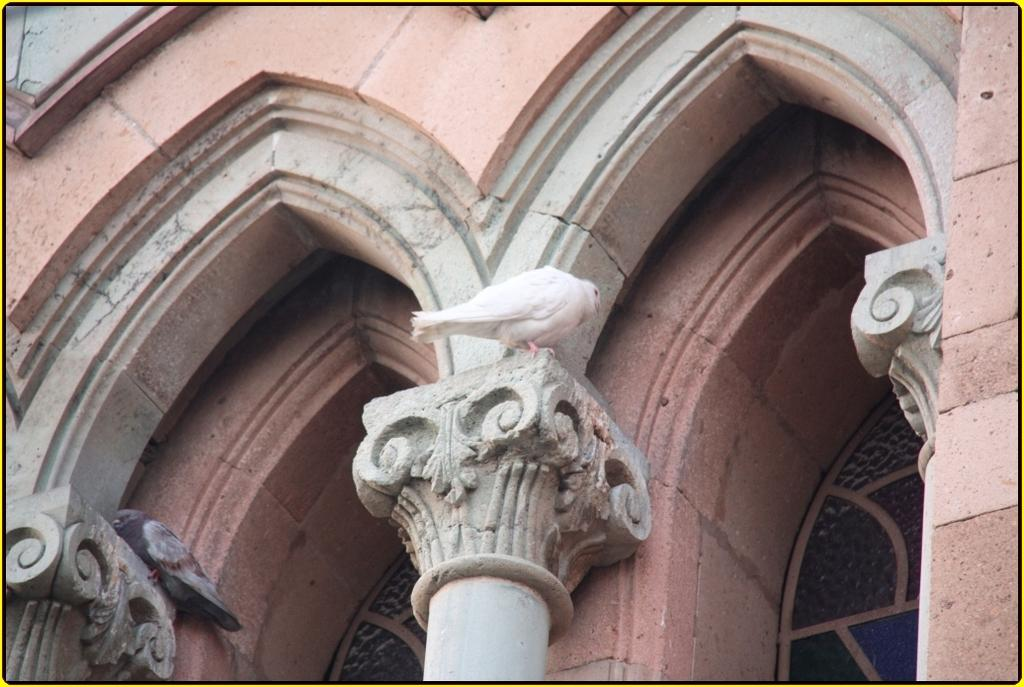What architectural features are present in the image? There are pillars and arches in the image. What type of animals can be seen in the image? There are two birds in the image. Where are the birds positioned in relation to the pillars? The birds are sitting on the pillars. What type of suit is the force wearing in the image? There is no suit or force present in the image; it features pillars, arches, and birds. Can you provide an example of a similar architectural design to the one shown in the image? It is not possible to provide an example of a similar architectural design based solely on the information provided in the image. 